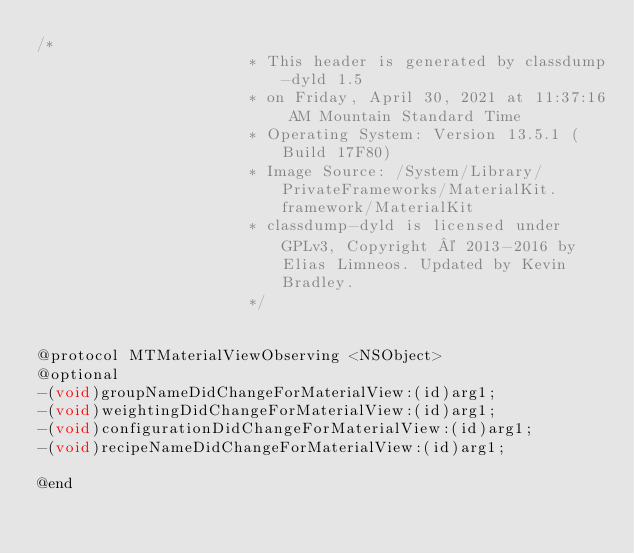<code> <loc_0><loc_0><loc_500><loc_500><_C_>/*
                       * This header is generated by classdump-dyld 1.5
                       * on Friday, April 30, 2021 at 11:37:16 AM Mountain Standard Time
                       * Operating System: Version 13.5.1 (Build 17F80)
                       * Image Source: /System/Library/PrivateFrameworks/MaterialKit.framework/MaterialKit
                       * classdump-dyld is licensed under GPLv3, Copyright © 2013-2016 by Elias Limneos. Updated by Kevin Bradley.
                       */


@protocol MTMaterialViewObserving <NSObject>
@optional
-(void)groupNameDidChangeForMaterialView:(id)arg1;
-(void)weightingDidChangeForMaterialView:(id)arg1;
-(void)configurationDidChangeForMaterialView:(id)arg1;
-(void)recipeNameDidChangeForMaterialView:(id)arg1;

@end

</code> 